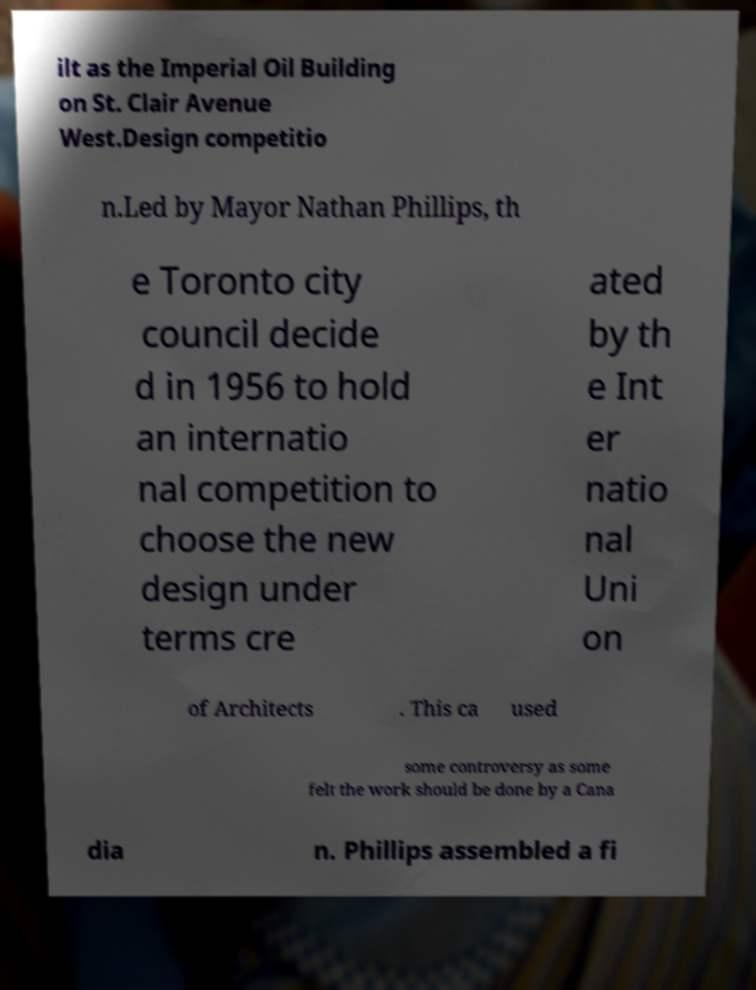Please read and relay the text visible in this image. What does it say? ilt as the Imperial Oil Building on St. Clair Avenue West.Design competitio n.Led by Mayor Nathan Phillips, th e Toronto city council decide d in 1956 to hold an internatio nal competition to choose the new design under terms cre ated by th e Int er natio nal Uni on of Architects . This ca used some controversy as some felt the work should be done by a Cana dia n. Phillips assembled a fi 